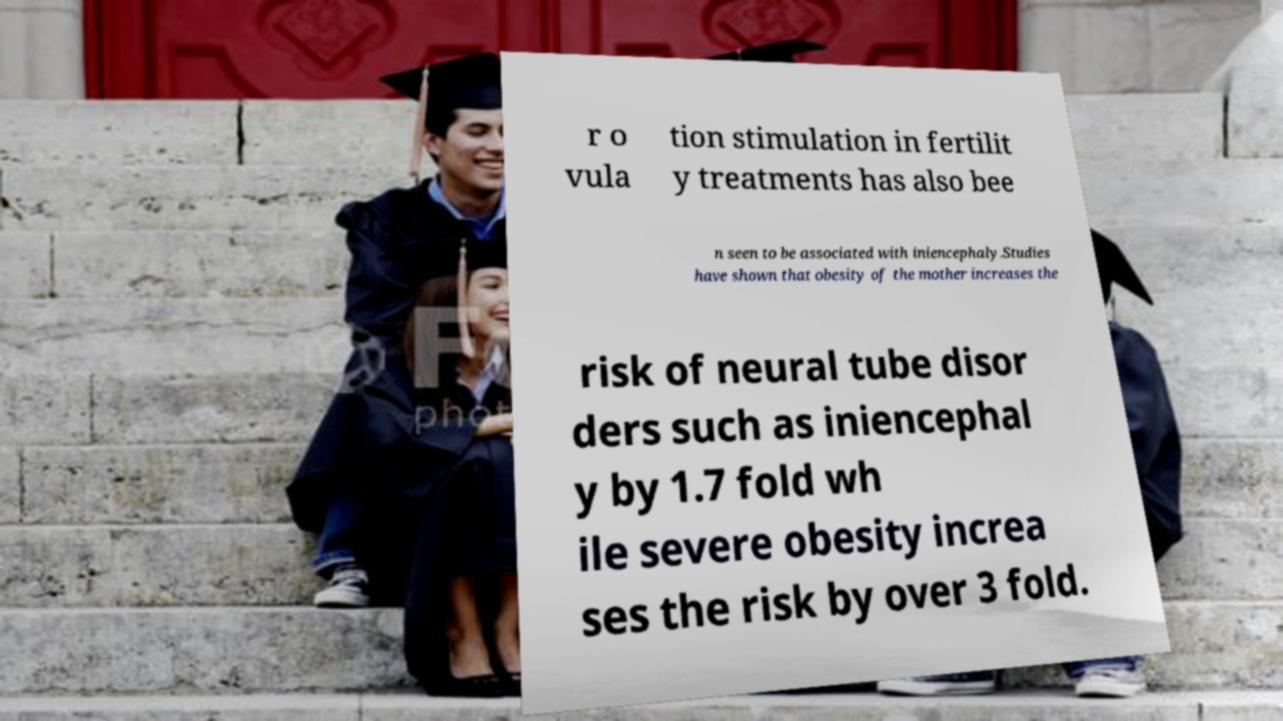Please identify and transcribe the text found in this image. r o vula tion stimulation in fertilit y treatments has also bee n seen to be associated with iniencephaly.Studies have shown that obesity of the mother increases the risk of neural tube disor ders such as iniencephal y by 1.7 fold wh ile severe obesity increa ses the risk by over 3 fold. 